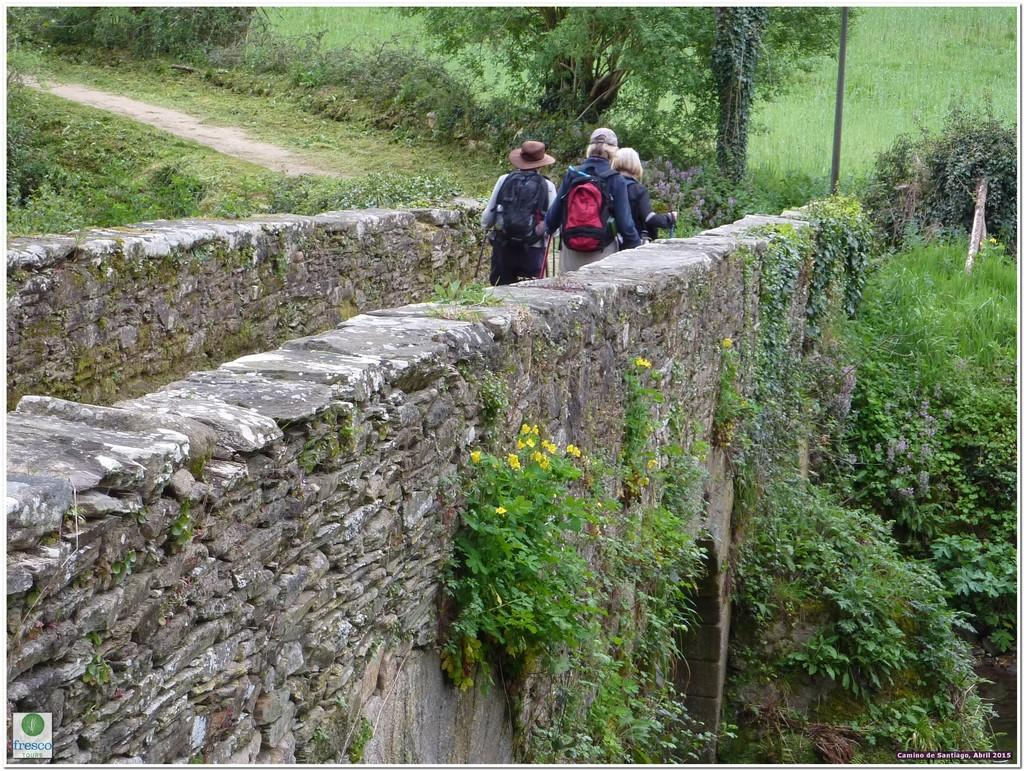What are the people in the image wearing? The people in the image are wearing bags. What type of natural elements can be seen in the image? There are trees in the image. What type of man-made structure is present in the image? There is a wall in the image. What type of flowers can be seen on the plants in the image? There are yellow color flowers on the plants in the image. What type of blade is being used by the fireman in the image? There is no fireman or blade present in the image. What type of bird can be seen flying in the image? There is no bird present in the image. 